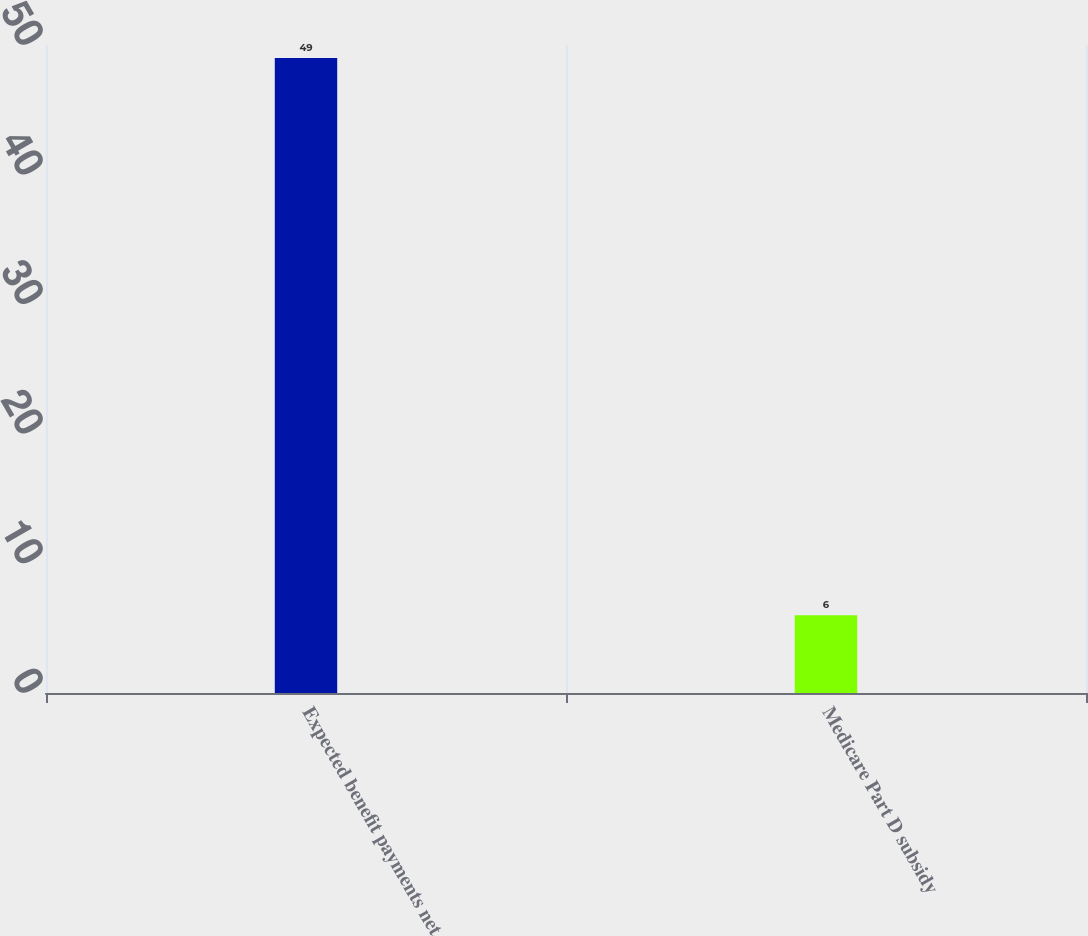<chart> <loc_0><loc_0><loc_500><loc_500><bar_chart><fcel>Expected benefit payments net<fcel>Medicare Part D subsidy<nl><fcel>49<fcel>6<nl></chart> 